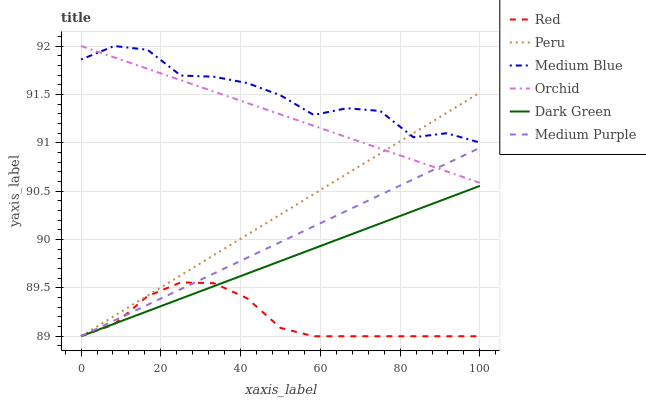Does Red have the minimum area under the curve?
Answer yes or no. Yes. Does Medium Blue have the maximum area under the curve?
Answer yes or no. Yes. Does Medium Purple have the minimum area under the curve?
Answer yes or no. No. Does Medium Purple have the maximum area under the curve?
Answer yes or no. No. Is Dark Green the smoothest?
Answer yes or no. Yes. Is Medium Blue the roughest?
Answer yes or no. Yes. Is Medium Purple the smoothest?
Answer yes or no. No. Is Medium Purple the roughest?
Answer yes or no. No. Does Medium Purple have the lowest value?
Answer yes or no. Yes. Does Orchid have the lowest value?
Answer yes or no. No. Does Orchid have the highest value?
Answer yes or no. Yes. Does Medium Purple have the highest value?
Answer yes or no. No. Is Red less than Medium Blue?
Answer yes or no. Yes. Is Medium Blue greater than Dark Green?
Answer yes or no. Yes. Does Medium Purple intersect Red?
Answer yes or no. Yes. Is Medium Purple less than Red?
Answer yes or no. No. Is Medium Purple greater than Red?
Answer yes or no. No. Does Red intersect Medium Blue?
Answer yes or no. No. 